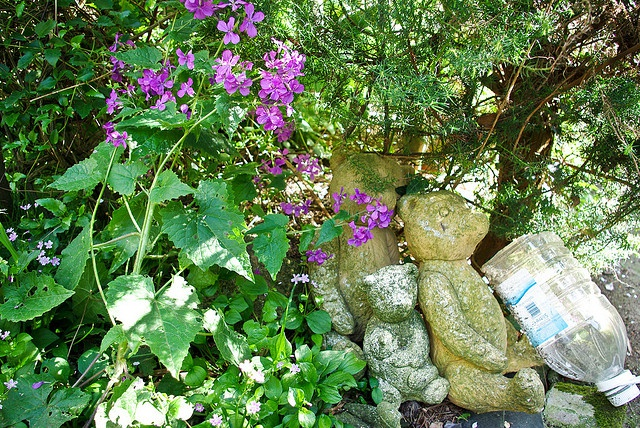Describe the objects in this image and their specific colors. I can see teddy bear in darkgreen, olive, khaki, and tan tones, bottle in darkgreen, white, darkgray, beige, and lightblue tones, teddy bear in darkgreen, olive, and green tones, and teddy bear in darkgreen, ivory, darkgray, and green tones in this image. 